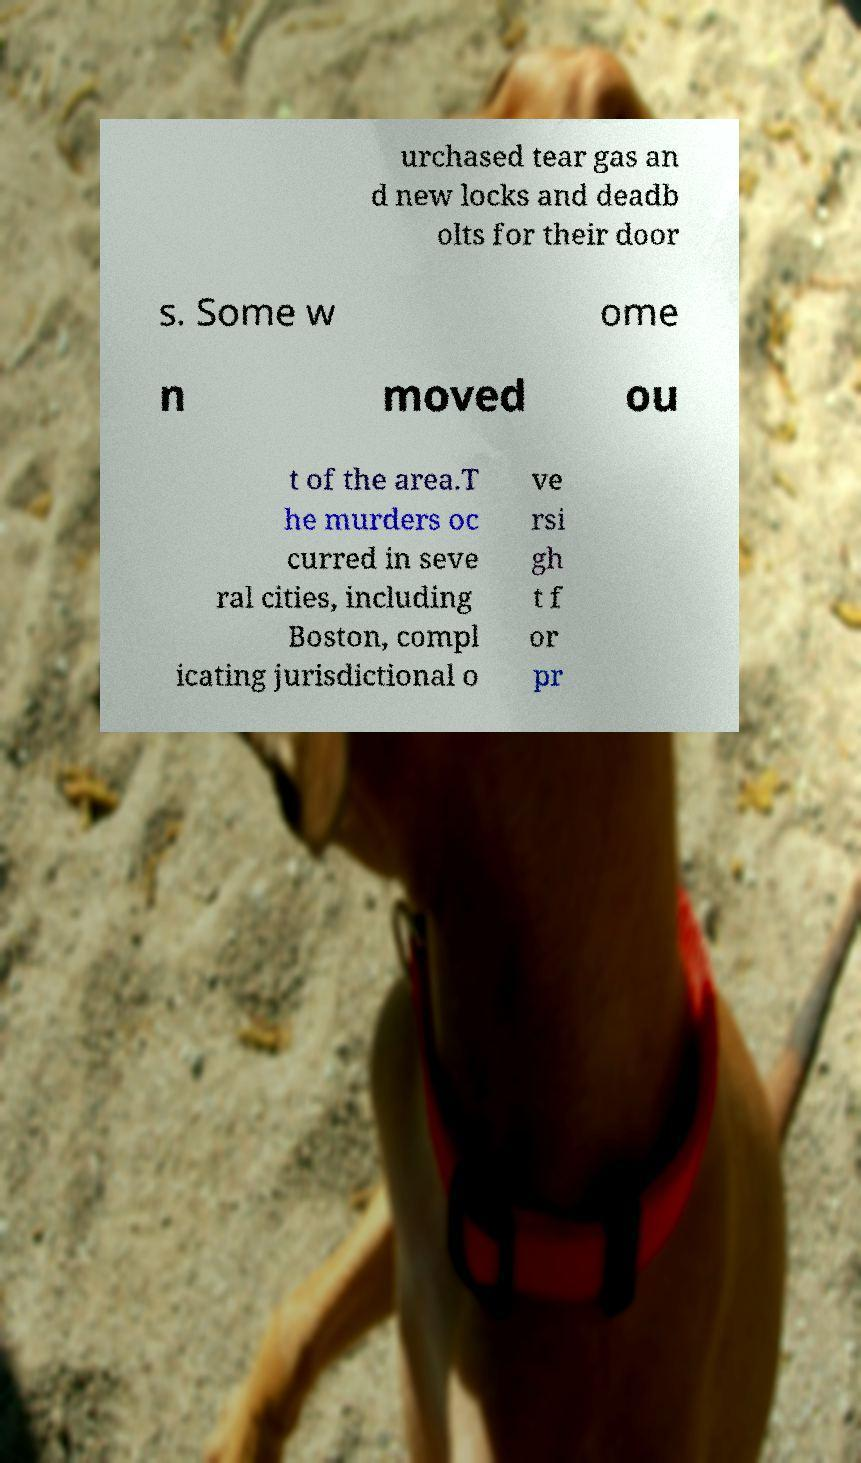For documentation purposes, I need the text within this image transcribed. Could you provide that? urchased tear gas an d new locks and deadb olts for their door s. Some w ome n moved ou t of the area.T he murders oc curred in seve ral cities, including Boston, compl icating jurisdictional o ve rsi gh t f or pr 